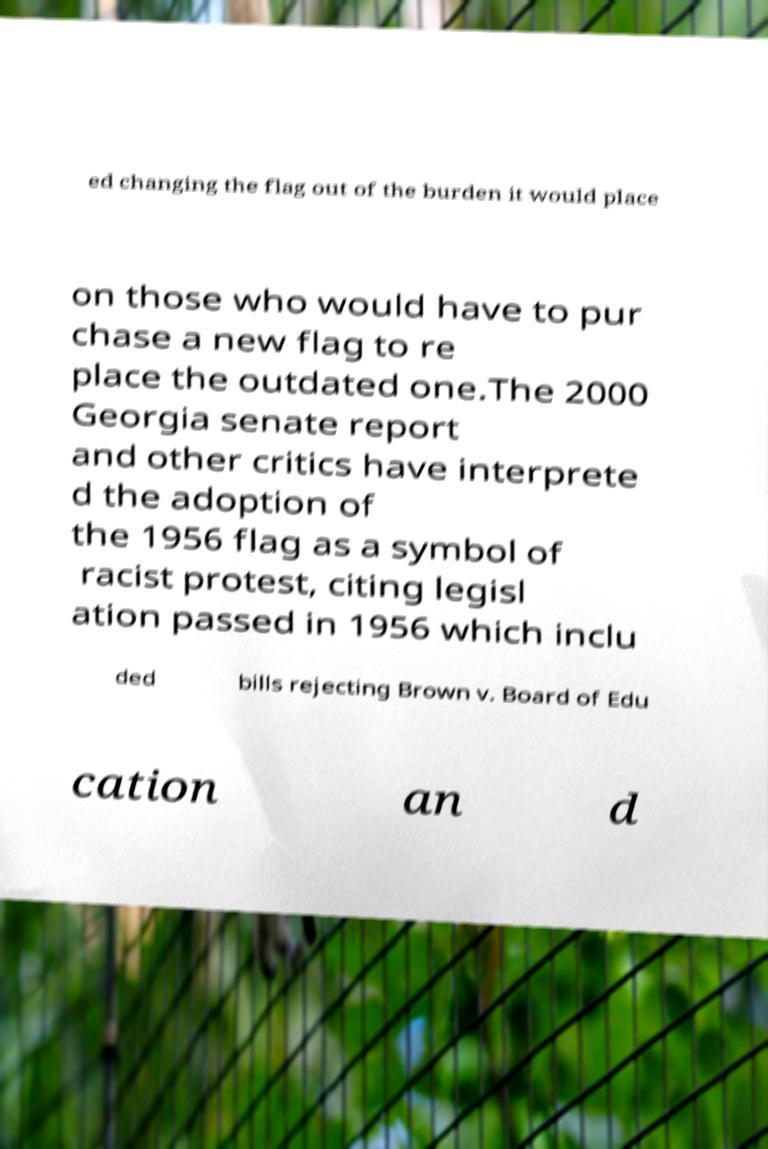Could you assist in decoding the text presented in this image and type it out clearly? ed changing the flag out of the burden it would place on those who would have to pur chase a new flag to re place the outdated one.The 2000 Georgia senate report and other critics have interprete d the adoption of the 1956 flag as a symbol of racist protest, citing legisl ation passed in 1956 which inclu ded bills rejecting Brown v. Board of Edu cation an d 